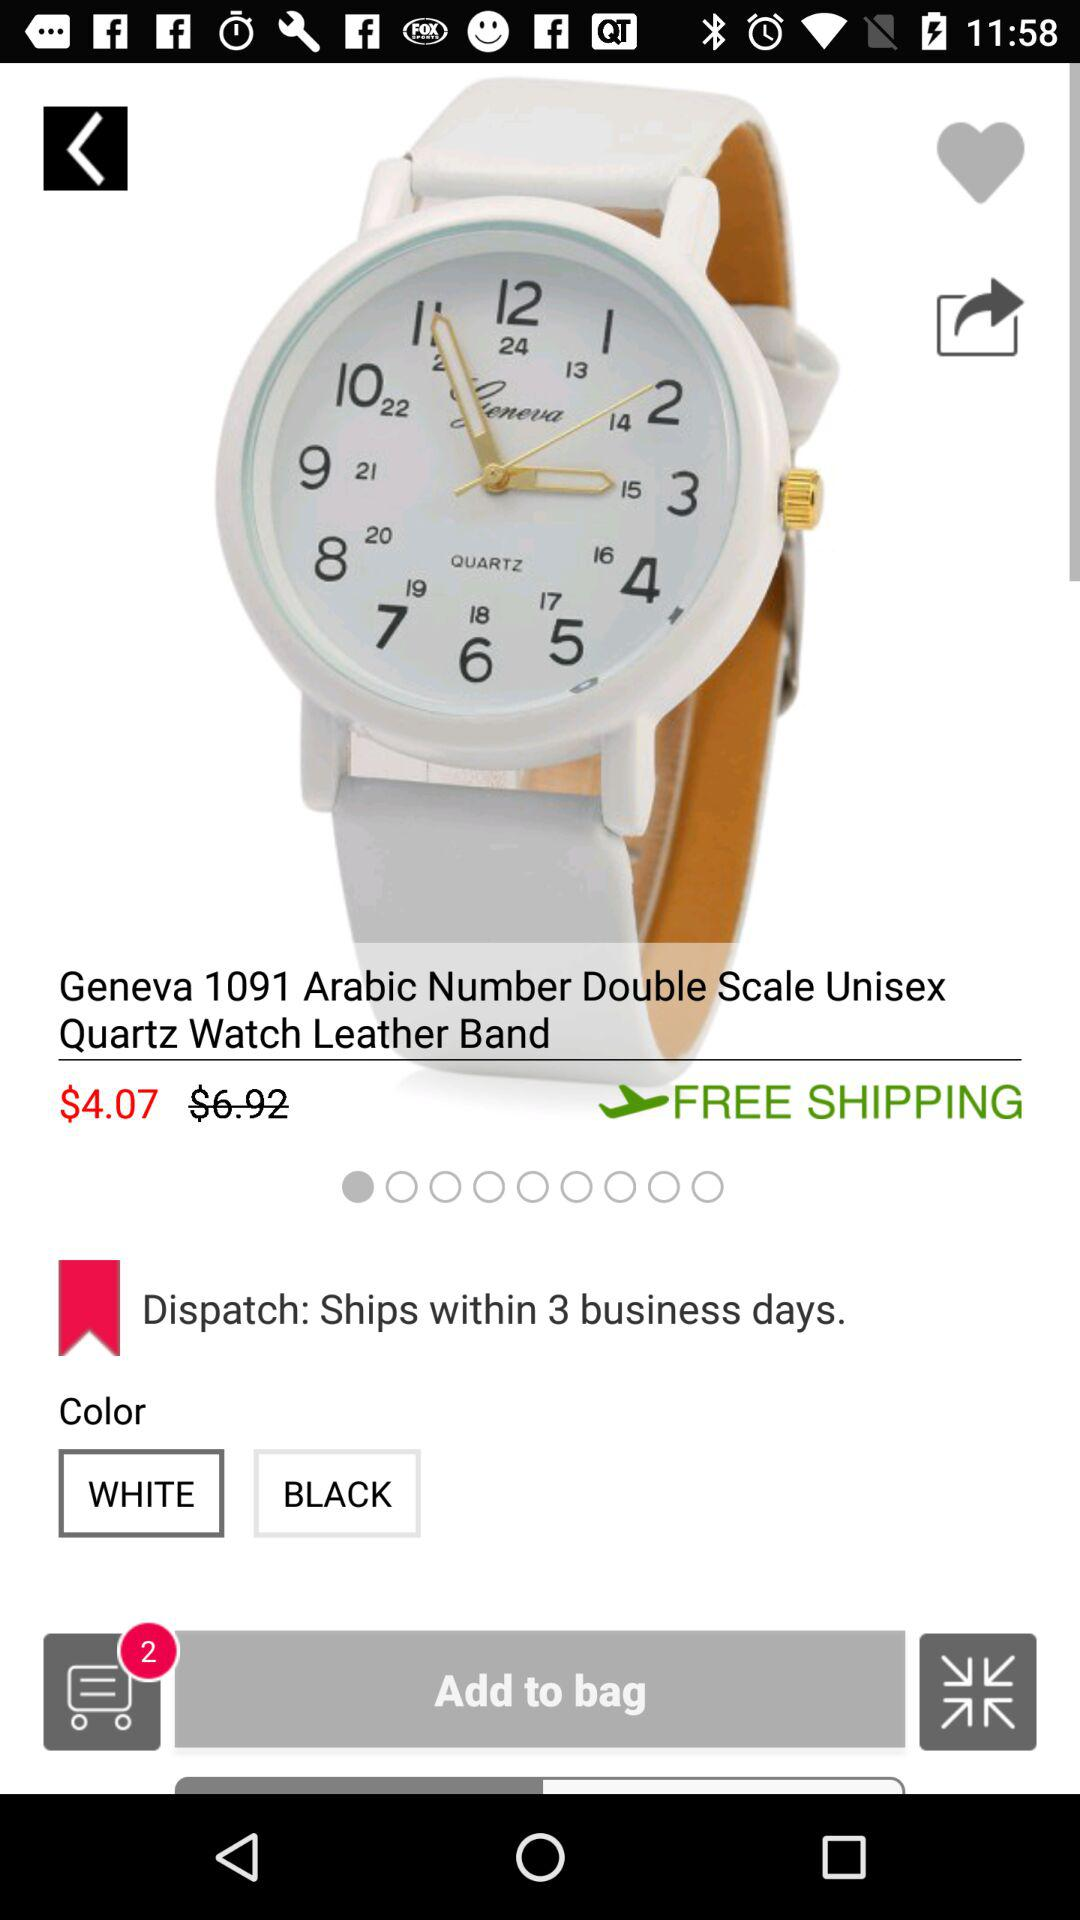How many colors does the watch come in?
Answer the question using a single word or phrase. 2 